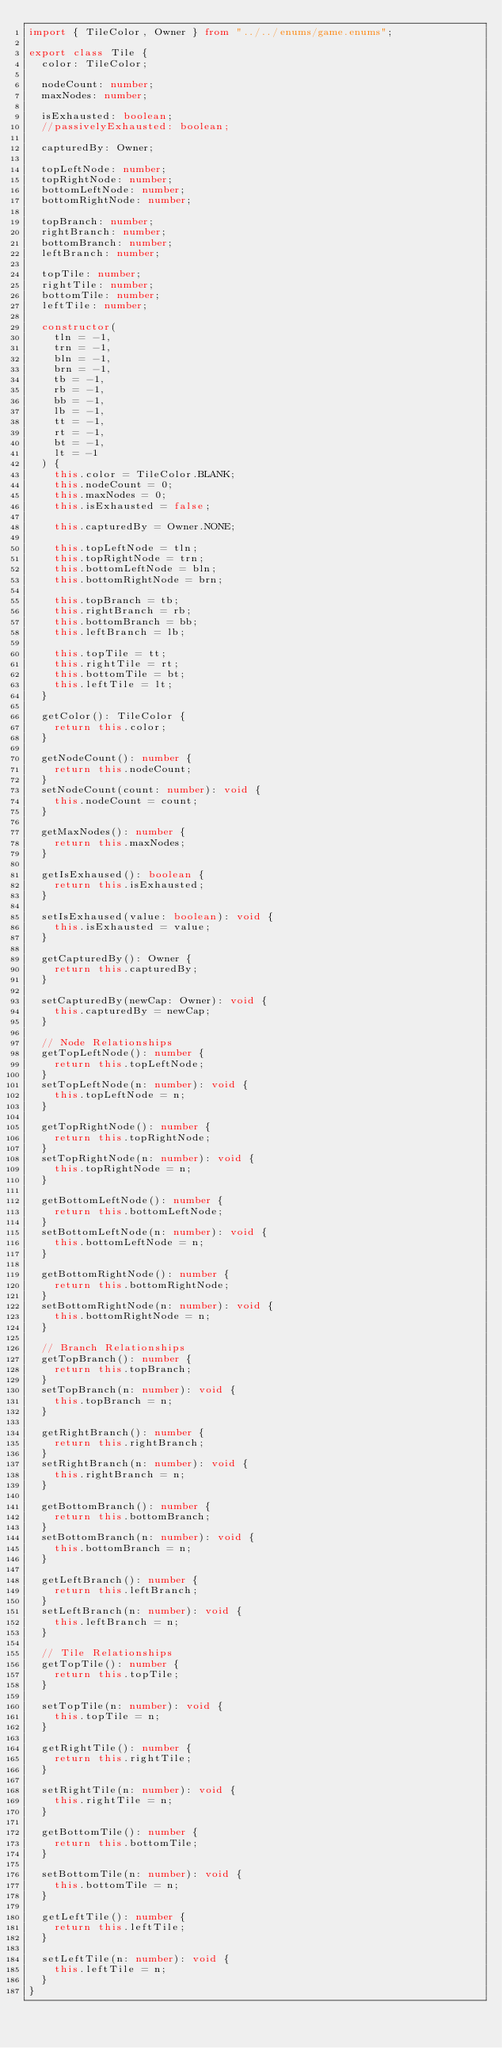Convert code to text. <code><loc_0><loc_0><loc_500><loc_500><_TypeScript_>import { TileColor, Owner } from "../../enums/game.enums";

export class Tile {
  color: TileColor;

  nodeCount: number;
  maxNodes: number;

  isExhausted: boolean;
  //passivelyExhausted: boolean;

  capturedBy: Owner;

  topLeftNode: number;
  topRightNode: number;
  bottomLeftNode: number;
  bottomRightNode: number;

  topBranch: number;
  rightBranch: number;
  bottomBranch: number;
  leftBranch: number;

  topTile: number;
  rightTile: number;
  bottomTile: number;
  leftTile: number;

  constructor(
    tln = -1,
    trn = -1,
    bln = -1,
    brn = -1,
    tb = -1,
    rb = -1,
    bb = -1,
    lb = -1,
    tt = -1,
    rt = -1,
    bt = -1,
    lt = -1
  ) {
    this.color = TileColor.BLANK;
    this.nodeCount = 0;
    this.maxNodes = 0;
    this.isExhausted = false;

    this.capturedBy = Owner.NONE;

    this.topLeftNode = tln;
    this.topRightNode = trn;
    this.bottomLeftNode = bln;
    this.bottomRightNode = brn;

    this.topBranch = tb;
    this.rightBranch = rb;
    this.bottomBranch = bb;
    this.leftBranch = lb;

    this.topTile = tt;
    this.rightTile = rt;
    this.bottomTile = bt;
    this.leftTile = lt;
  }

  getColor(): TileColor {
    return this.color;
  }

  getNodeCount(): number {
    return this.nodeCount;
  }
  setNodeCount(count: number): void {
    this.nodeCount = count;
  }

  getMaxNodes(): number {
    return this.maxNodes;
  }

  getIsExhaused(): boolean {
    return this.isExhausted;
  }

  setIsExhaused(value: boolean): void {
    this.isExhausted = value;
  }

  getCapturedBy(): Owner {
    return this.capturedBy;
  }

  setCapturedBy(newCap: Owner): void {
    this.capturedBy = newCap;
  }

  // Node Relationships
  getTopLeftNode(): number {
    return this.topLeftNode;
  }
  setTopLeftNode(n: number): void {
    this.topLeftNode = n;
  }

  getTopRightNode(): number {
    return this.topRightNode;
  }
  setTopRightNode(n: number): void {
    this.topRightNode = n;
  }

  getBottomLeftNode(): number {
    return this.bottomLeftNode;
  }
  setBottomLeftNode(n: number): void {
    this.bottomLeftNode = n;
  }

  getBottomRightNode(): number {
    return this.bottomRightNode;
  }
  setBottomRightNode(n: number): void {
    this.bottomRightNode = n;
  }

  // Branch Relationships
  getTopBranch(): number {
    return this.topBranch;
  }
  setTopBranch(n: number): void {
    this.topBranch = n;
  }

  getRightBranch(): number {
    return this.rightBranch;
  }
  setRightBranch(n: number): void {
    this.rightBranch = n;
  }

  getBottomBranch(): number {
    return this.bottomBranch;
  }
  setBottomBranch(n: number): void {
    this.bottomBranch = n;
  }

  getLeftBranch(): number {
    return this.leftBranch;
  }
  setLeftBranch(n: number): void {
    this.leftBranch = n;
  }

  // Tile Relationships
  getTopTile(): number {
    return this.topTile;
  }

  setTopTile(n: number): void {
    this.topTile = n;
  }

  getRightTile(): number {
    return this.rightTile;
  }

  setRightTile(n: number): void {
    this.rightTile = n;
  }

  getBottomTile(): number {
    return this.bottomTile;
  }

  setBottomTile(n: number): void {
    this.bottomTile = n;
  }

  getLeftTile(): number {
    return this.leftTile;
  }

  setLeftTile(n: number): void {
    this.leftTile = n;
  }
}
</code> 